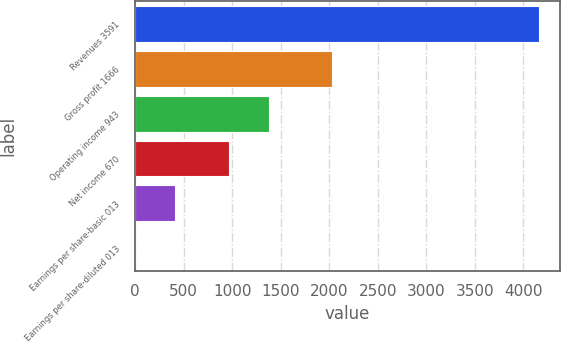<chart> <loc_0><loc_0><loc_500><loc_500><bar_chart><fcel>Revenues 3591<fcel>Gross profit 1666<fcel>Operating income 943<fcel>Net income 670<fcel>Earnings per share-basic 013<fcel>Earnings per share-diluted 013<nl><fcel>4163<fcel>2024<fcel>1383.28<fcel>967<fcel>416.46<fcel>0.18<nl></chart> 